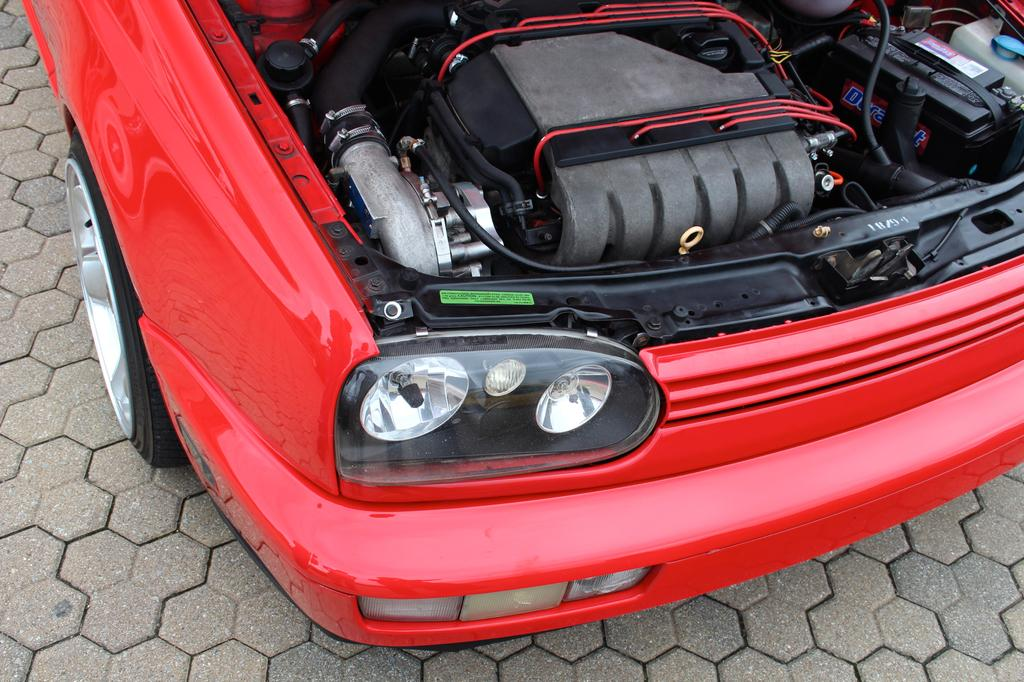What color is the car in the image? The car in the image is red. What part of the car can be seen in the image? The car's engine is visible in the image. What else can be seen in the image besides the car? There are wires visible in the image. Where is the car located in the image? The car is on a path. What type of paint is being used to cover the engine in the image? There is no paint visible on the engine in the image. The engine is not being painted or covered with any type of paint. 